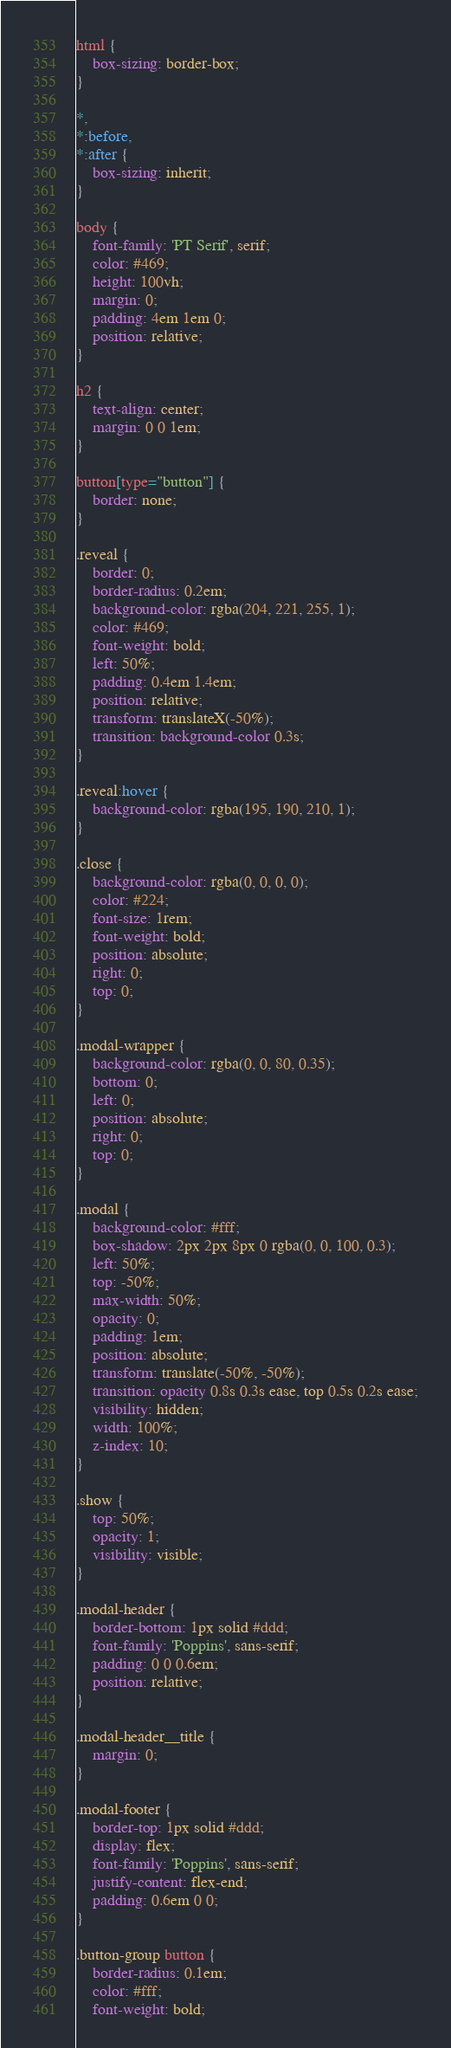<code> <loc_0><loc_0><loc_500><loc_500><_CSS_>html {
    box-sizing: border-box;
}

*,
*:before,
*:after {
    box-sizing: inherit;
}

body {
    font-family: 'PT Serif', serif;
    color: #469;
    height: 100vh;
    margin: 0;
    padding: 4em 1em 0;
    position: relative;
}

h2 {
    text-align: center;
    margin: 0 0 1em;
}

button[type="button"] {
    border: none;
}

.reveal {
    border: 0;
    border-radius: 0.2em;
    background-color: rgba(204, 221, 255, 1);
    color: #469;
    font-weight: bold;
    left: 50%;
    padding: 0.4em 1.4em;
    position: relative;
    transform: translateX(-50%);
    transition: background-color 0.3s;
}

.reveal:hover {
    background-color: rgba(195, 190, 210, 1);
}

.close {
    background-color: rgba(0, 0, 0, 0);
    color: #224;
    font-size: 1rem;
    font-weight: bold;
    position: absolute;
    right: 0;
    top: 0;
}

.modal-wrapper {
    background-color: rgba(0, 0, 80, 0.35);
    bottom: 0;
    left: 0;
    position: absolute;
    right: 0;
    top: 0;
}

.modal {
    background-color: #fff;
    box-shadow: 2px 2px 8px 0 rgba(0, 0, 100, 0.3);
    left: 50%;
    top: -50%;
    max-width: 50%;
    opacity: 0;
    padding: 1em;
    position: absolute;
    transform: translate(-50%, -50%);
    transition: opacity 0.8s 0.3s ease, top 0.5s 0.2s ease;
    visibility: hidden;
    width: 100%;
    z-index: 10;
}

.show {
    top: 50%;
    opacity: 1;
    visibility: visible;
}

.modal-header {
    border-bottom: 1px solid #ddd;
    font-family: 'Poppins', sans-serif;
    padding: 0 0 0.6em;
    position: relative;
}

.modal-header__title {
    margin: 0;
}

.modal-footer {
    border-top: 1px solid #ddd;
    display: flex;
    font-family: 'Poppins', sans-serif;
    justify-content: flex-end;
    padding: 0.6em 0 0;
}

.button-group button {
    border-radius: 0.1em;
    color: #fff;
    font-weight: bold;</code> 